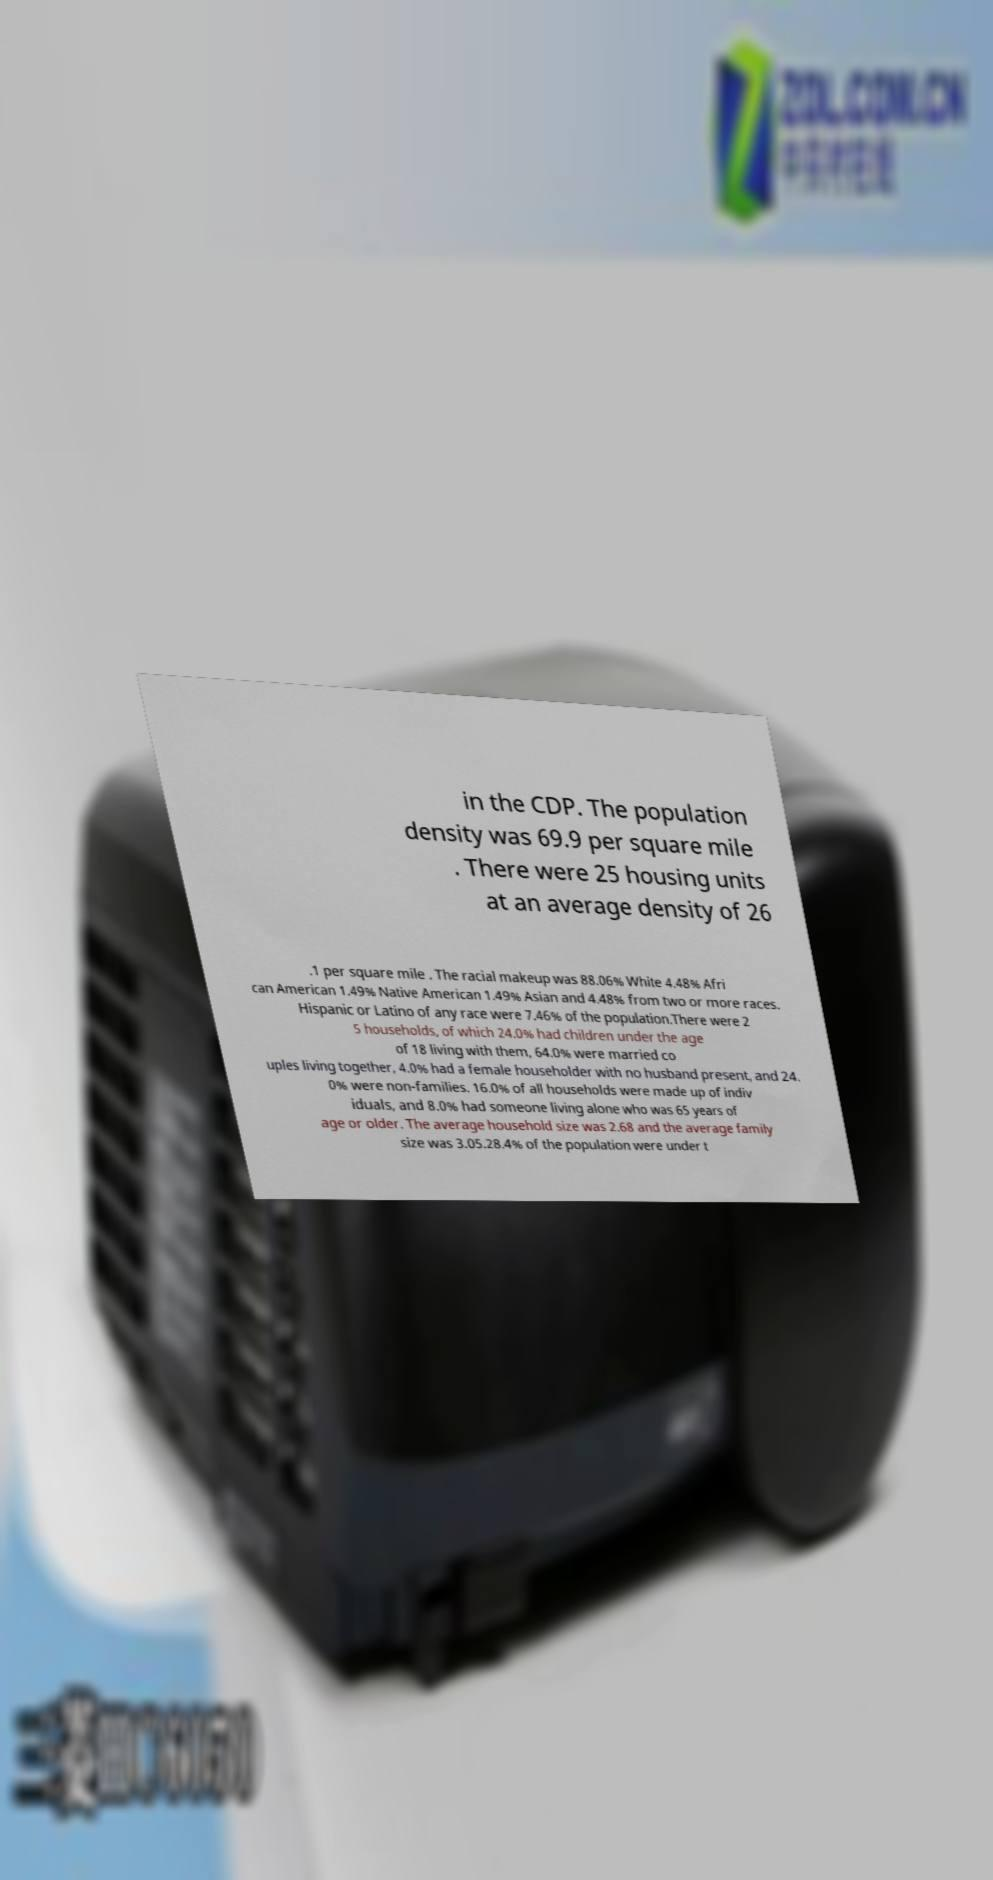Can you accurately transcribe the text from the provided image for me? in the CDP. The population density was 69.9 per square mile . There were 25 housing units at an average density of 26 .1 per square mile . The racial makeup was 88.06% White 4.48% Afri can American 1.49% Native American 1.49% Asian and 4.48% from two or more races. Hispanic or Latino of any race were 7.46% of the population.There were 2 5 households, of which 24.0% had children under the age of 18 living with them, 64.0% were married co uples living together, 4.0% had a female householder with no husband present, and 24. 0% were non-families. 16.0% of all households were made up of indiv iduals, and 8.0% had someone living alone who was 65 years of age or older. The average household size was 2.68 and the average family size was 3.05.28.4% of the population were under t 